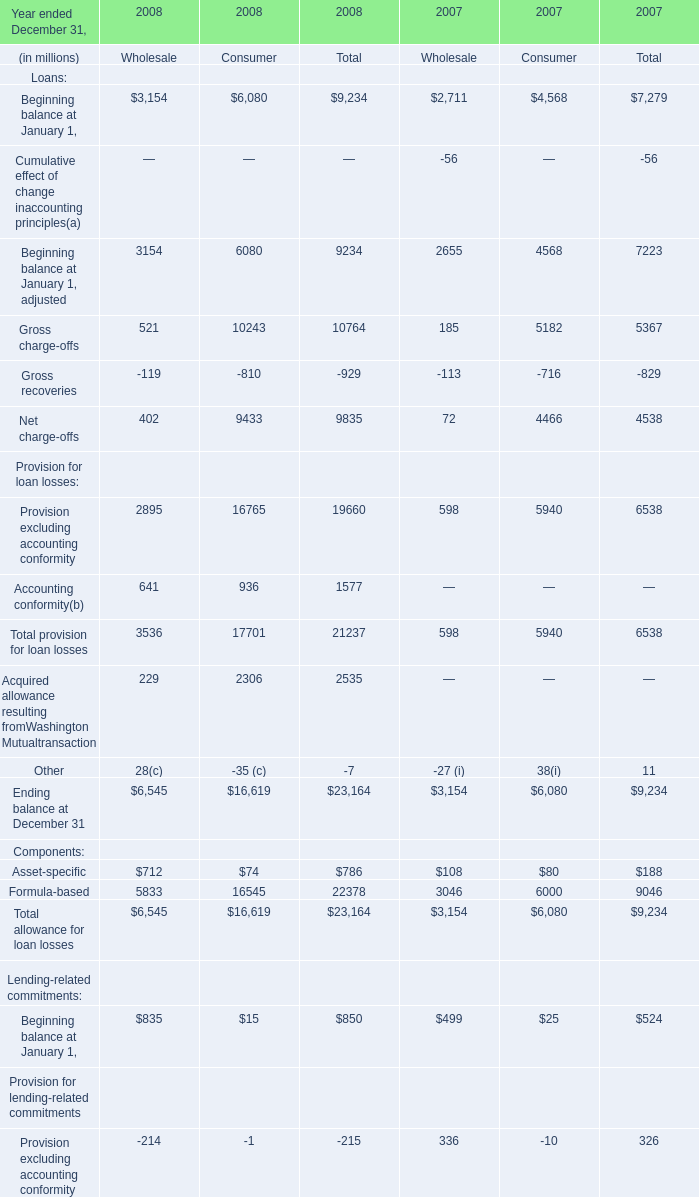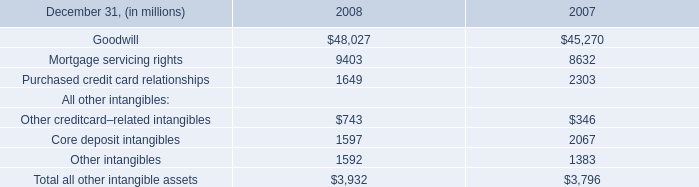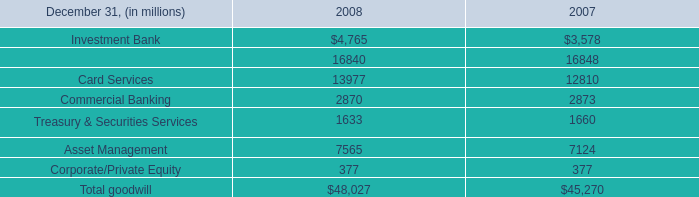In which year is Gross charge-offs positive for total? 
Answer: 2007 2008. 